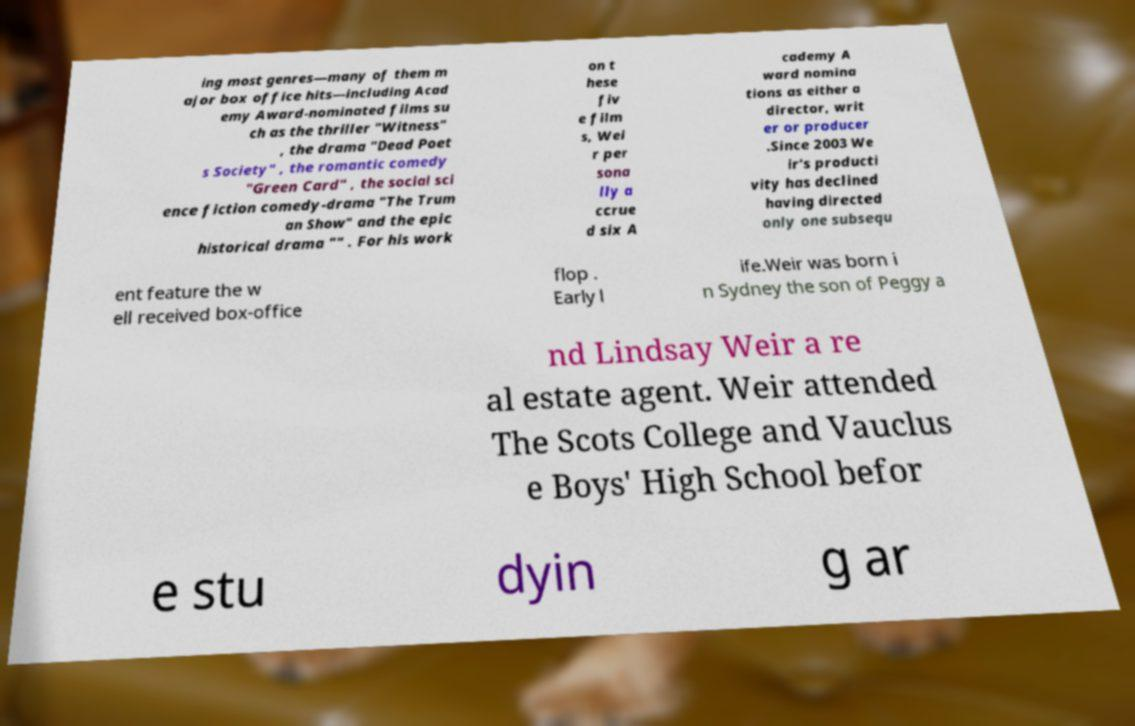Please read and relay the text visible in this image. What does it say? ing most genres—many of them m ajor box office hits—including Acad emy Award-nominated films su ch as the thriller "Witness" , the drama "Dead Poet s Society" , the romantic comedy "Green Card" , the social sci ence fiction comedy-drama "The Trum an Show" and the epic historical drama "" . For his work on t hese fiv e film s, Wei r per sona lly a ccrue d six A cademy A ward nomina tions as either a director, writ er or producer .Since 2003 We ir's producti vity has declined having directed only one subsequ ent feature the w ell received box-office flop . Early l ife.Weir was born i n Sydney the son of Peggy a nd Lindsay Weir a re al estate agent. Weir attended The Scots College and Vauclus e Boys' High School befor e stu dyin g ar 